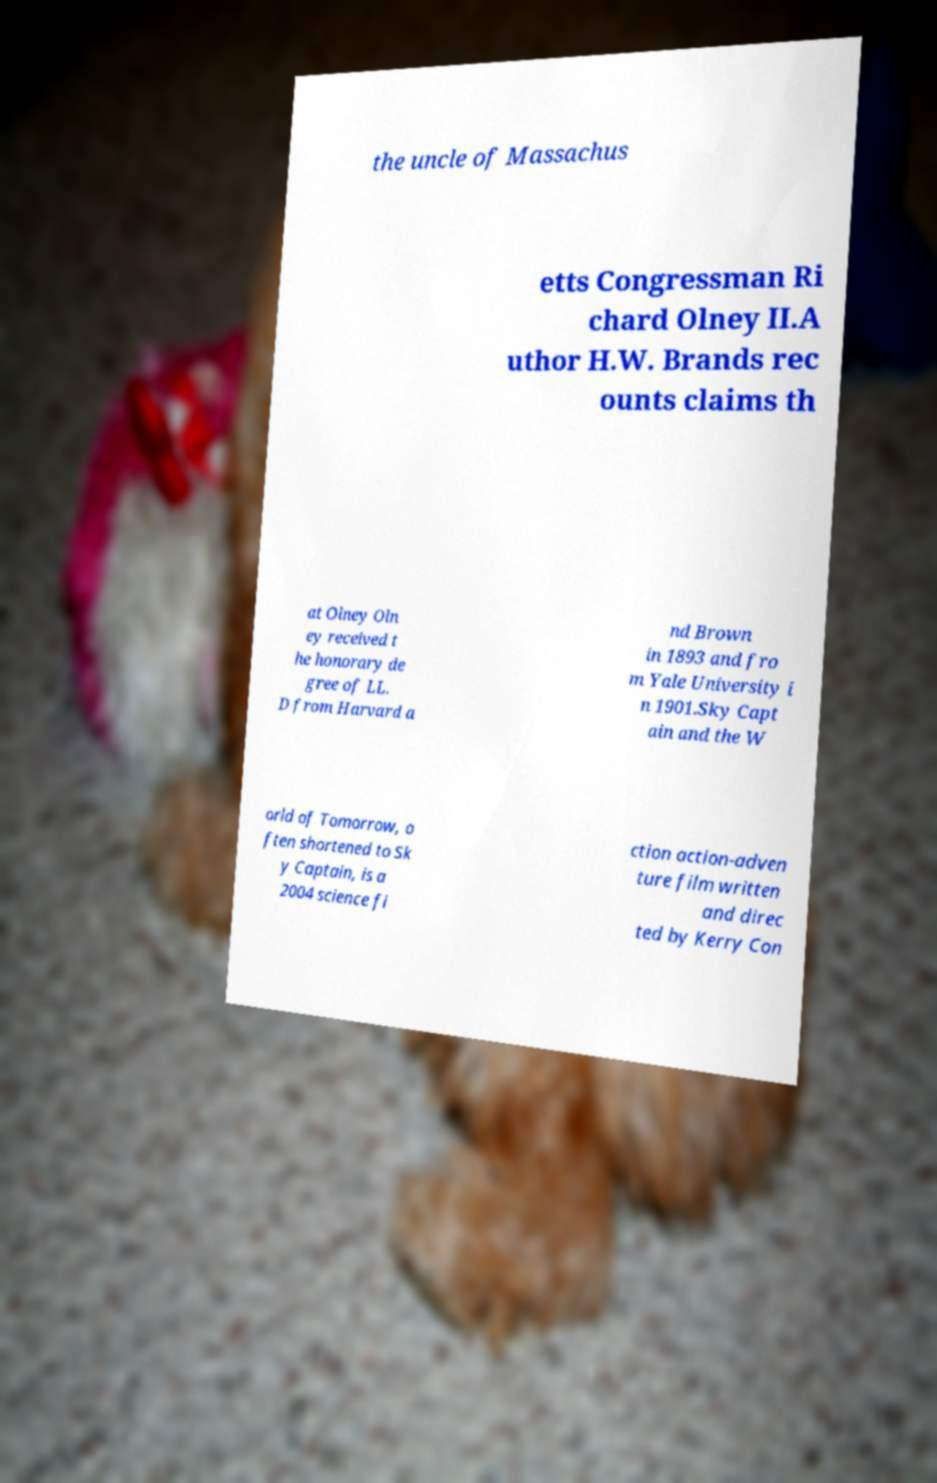Can you accurately transcribe the text from the provided image for me? the uncle of Massachus etts Congressman Ri chard Olney II.A uthor H.W. Brands rec ounts claims th at Olney Oln ey received t he honorary de gree of LL. D from Harvard a nd Brown in 1893 and fro m Yale University i n 1901.Sky Capt ain and the W orld of Tomorrow, o ften shortened to Sk y Captain, is a 2004 science fi ction action-adven ture film written and direc ted by Kerry Con 